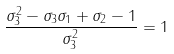Convert formula to latex. <formula><loc_0><loc_0><loc_500><loc_500>\frac { \sigma _ { 3 } ^ { 2 } - \sigma _ { 3 } \sigma _ { 1 } + \sigma _ { 2 } - 1 } { \sigma _ { 3 } ^ { 2 } } = 1</formula> 